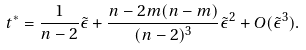Convert formula to latex. <formula><loc_0><loc_0><loc_500><loc_500>t ^ { \ast } = \frac { 1 } { n - 2 } \tilde { \epsilon } + \frac { n - 2 m ( n - m ) } { ( n - 2 ) ^ { 3 } } \tilde { \epsilon } ^ { 2 } + O ( \tilde { \epsilon } ^ { 3 } ) .</formula> 